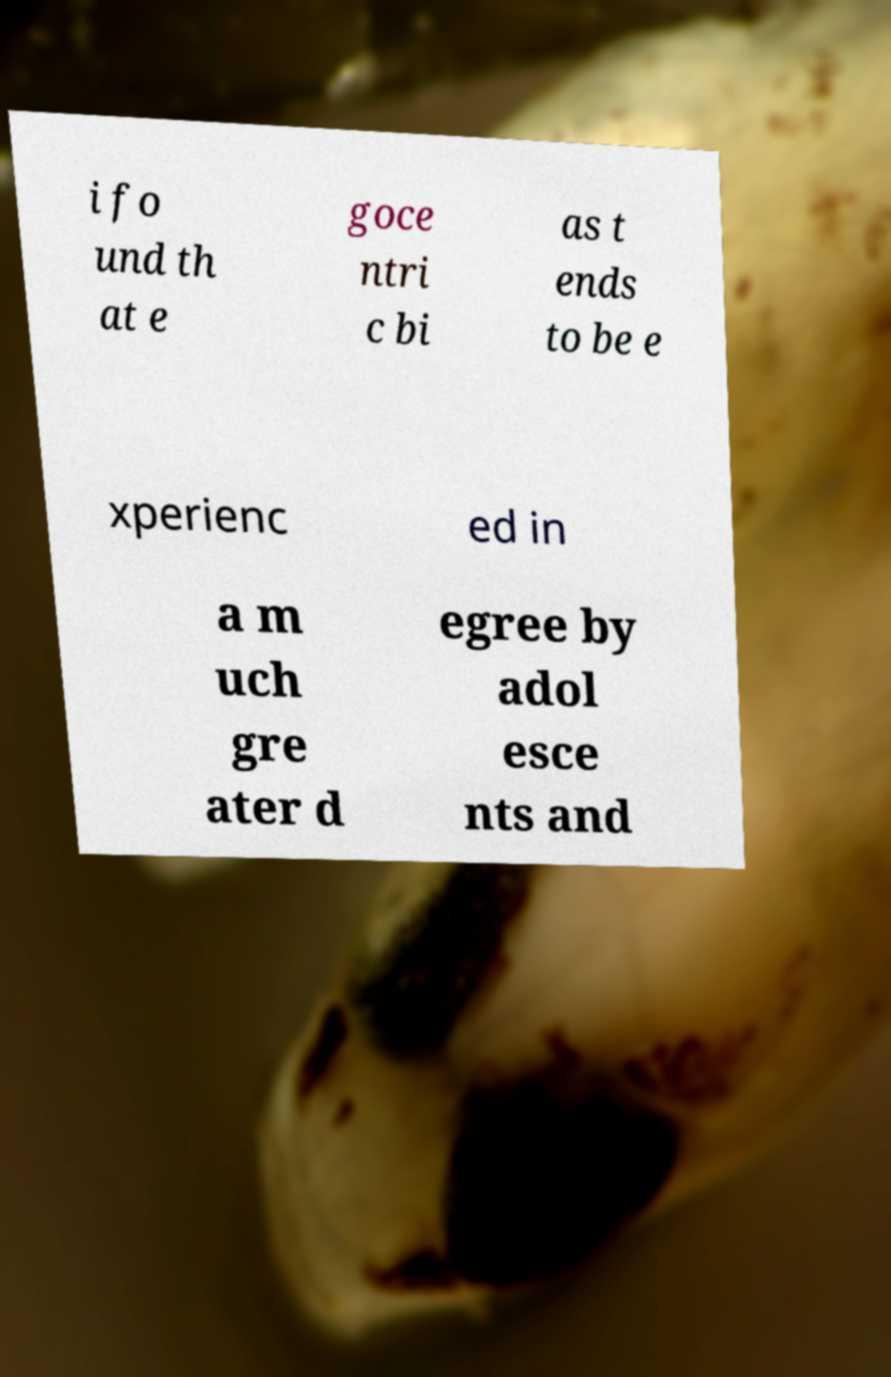For documentation purposes, I need the text within this image transcribed. Could you provide that? i fo und th at e goce ntri c bi as t ends to be e xperienc ed in a m uch gre ater d egree by adol esce nts and 